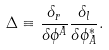<formula> <loc_0><loc_0><loc_500><loc_500>\Delta \equiv \frac { \delta _ { r } } { \delta \phi ^ { A } } \frac { \delta _ { l } } { \delta \phi _ { A } ^ { \ast } } .</formula> 